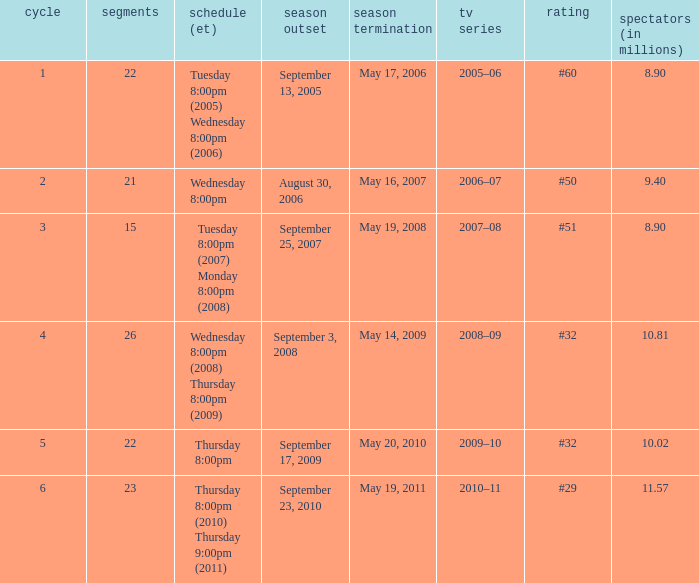How many seasons was the rank equal to #50? 1.0. 